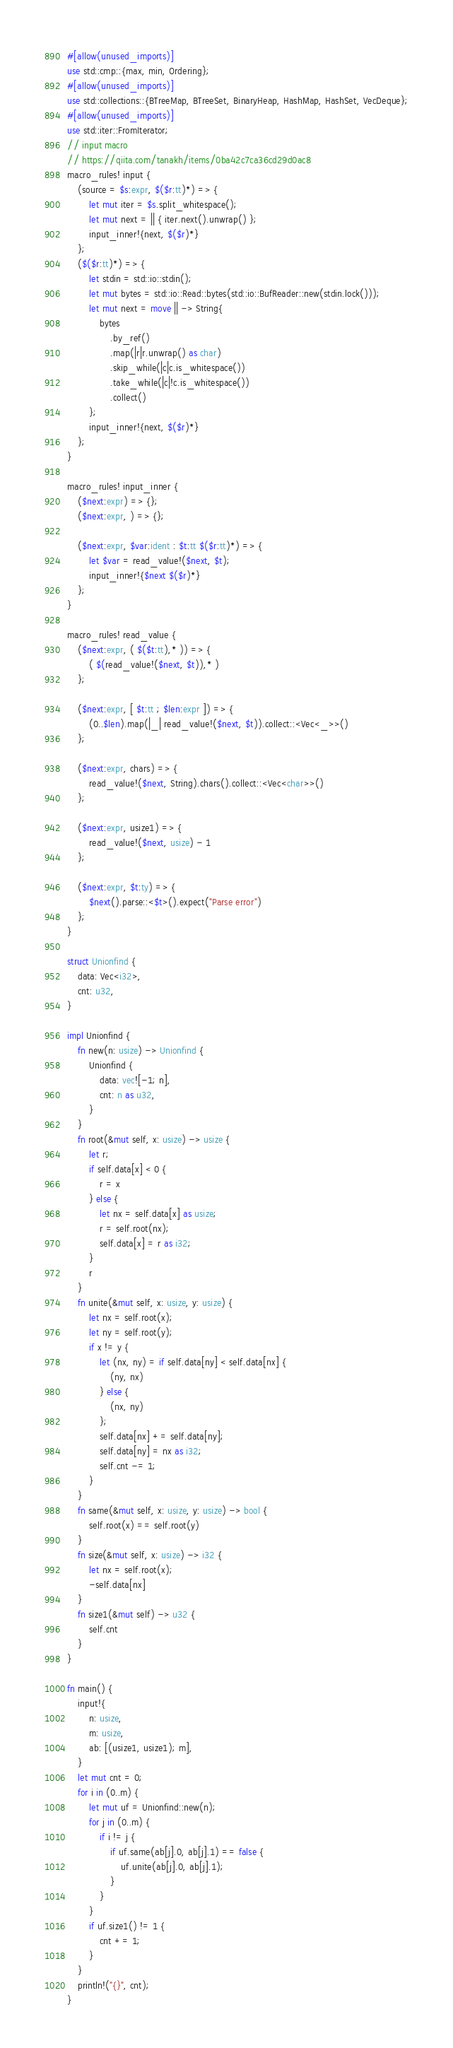Convert code to text. <code><loc_0><loc_0><loc_500><loc_500><_Rust_>#[allow(unused_imports)]
use std::cmp::{max, min, Ordering};
#[allow(unused_imports)]
use std::collections::{BTreeMap, BTreeSet, BinaryHeap, HashMap, HashSet, VecDeque};
#[allow(unused_imports)]
use std::iter::FromIterator;
// input macro
// https://qiita.com/tanakh/items/0ba42c7ca36cd29d0ac8
macro_rules! input {
    (source = $s:expr, $($r:tt)*) => {
        let mut iter = $s.split_whitespace();
        let mut next = || { iter.next().unwrap() };
        input_inner!{next, $($r)*}
    };
    ($($r:tt)*) => {
        let stdin = std::io::stdin();
        let mut bytes = std::io::Read::bytes(std::io::BufReader::new(stdin.lock()));
        let mut next = move || -> String{
            bytes
                .by_ref()
                .map(|r|r.unwrap() as char)
                .skip_while(|c|c.is_whitespace())
                .take_while(|c|!c.is_whitespace())
                .collect()
        };
        input_inner!{next, $($r)*}
    };
}

macro_rules! input_inner {
    ($next:expr) => {};
    ($next:expr, ) => {};

    ($next:expr, $var:ident : $t:tt $($r:tt)*) => {
        let $var = read_value!($next, $t);
        input_inner!{$next $($r)*}
    };
}

macro_rules! read_value {
    ($next:expr, ( $($t:tt),* )) => {
        ( $(read_value!($next, $t)),* )
    };

    ($next:expr, [ $t:tt ; $len:expr ]) => {
        (0..$len).map(|_| read_value!($next, $t)).collect::<Vec<_>>()
    };

    ($next:expr, chars) => {
        read_value!($next, String).chars().collect::<Vec<char>>()
    };

    ($next:expr, usize1) => {
        read_value!($next, usize) - 1
    };

    ($next:expr, $t:ty) => {
        $next().parse::<$t>().expect("Parse error")
    };
}

struct Unionfind {
    data: Vec<i32>,
    cnt: u32,
}

impl Unionfind {
    fn new(n: usize) -> Unionfind {
        Unionfind {
            data: vec![-1; n],
            cnt: n as u32,
        }
    }
    fn root(&mut self, x: usize) -> usize {
        let r;
        if self.data[x] < 0 {
            r = x
        } else {
            let nx = self.data[x] as usize;
            r = self.root(nx);
            self.data[x] = r as i32;
        }
        r
    }
    fn unite(&mut self, x: usize, y: usize) {
        let nx = self.root(x);
        let ny = self.root(y);
        if x != y {
            let (nx, ny) = if self.data[ny] < self.data[nx] {
                (ny, nx)
            } else {
                (nx, ny)
            };
            self.data[nx] += self.data[ny];
            self.data[ny] = nx as i32;
            self.cnt -= 1;
        }
    }
    fn same(&mut self, x: usize, y: usize) -> bool {
        self.root(x) == self.root(y)
    }
    fn size(&mut self, x: usize) -> i32 {
        let nx = self.root(x);
        -self.data[nx]
    }
    fn size1(&mut self) -> u32 {
        self.cnt
    }
}

fn main() {
    input!{
        n: usize,
        m: usize,
        ab: [(usize1, usize1); m],
    }
    let mut cnt = 0;
    for i in (0..m) {
        let mut uf = Unionfind::new(n);
        for j in (0..m) {
            if i != j {
                if uf.same(ab[j].0, ab[j].1) == false {
                    uf.unite(ab[j].0, ab[j].1);
                }
            }
        }
        if uf.size1() != 1 {
            cnt += 1;
        }
    }
    println!("{}", cnt);
}
</code> 